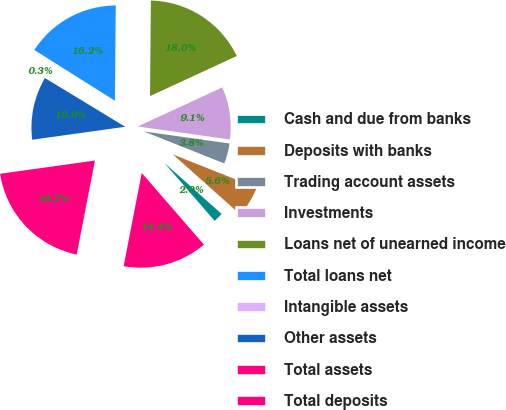<chart> <loc_0><loc_0><loc_500><loc_500><pie_chart><fcel>Cash and due from banks<fcel>Deposits with banks<fcel>Trading account assets<fcel>Investments<fcel>Loans net of unearned income<fcel>Total loans net<fcel>Intangible assets<fcel>Other assets<fcel>Total assets<fcel>Total deposits<nl><fcel>2.03%<fcel>5.57%<fcel>3.8%<fcel>9.11%<fcel>17.97%<fcel>16.2%<fcel>0.26%<fcel>10.89%<fcel>19.74%<fcel>14.43%<nl></chart> 